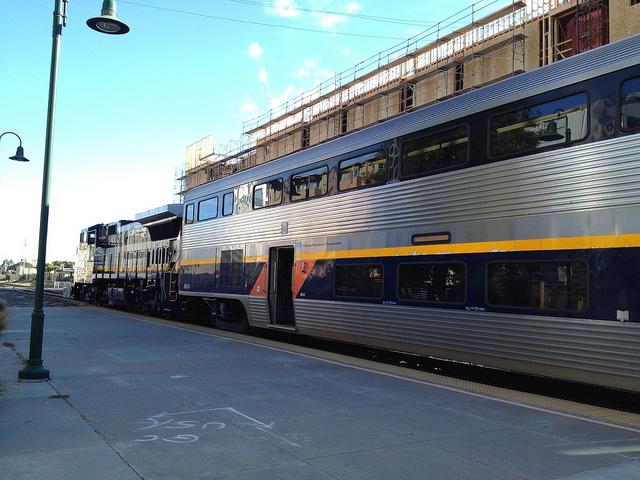Is this a transportation station?
Be succinct. Yes. Is this a passenger train?
Quick response, please. Yes. Is this train moving?
Concise answer only. No. What color is the train?
Short answer required. Silver. 